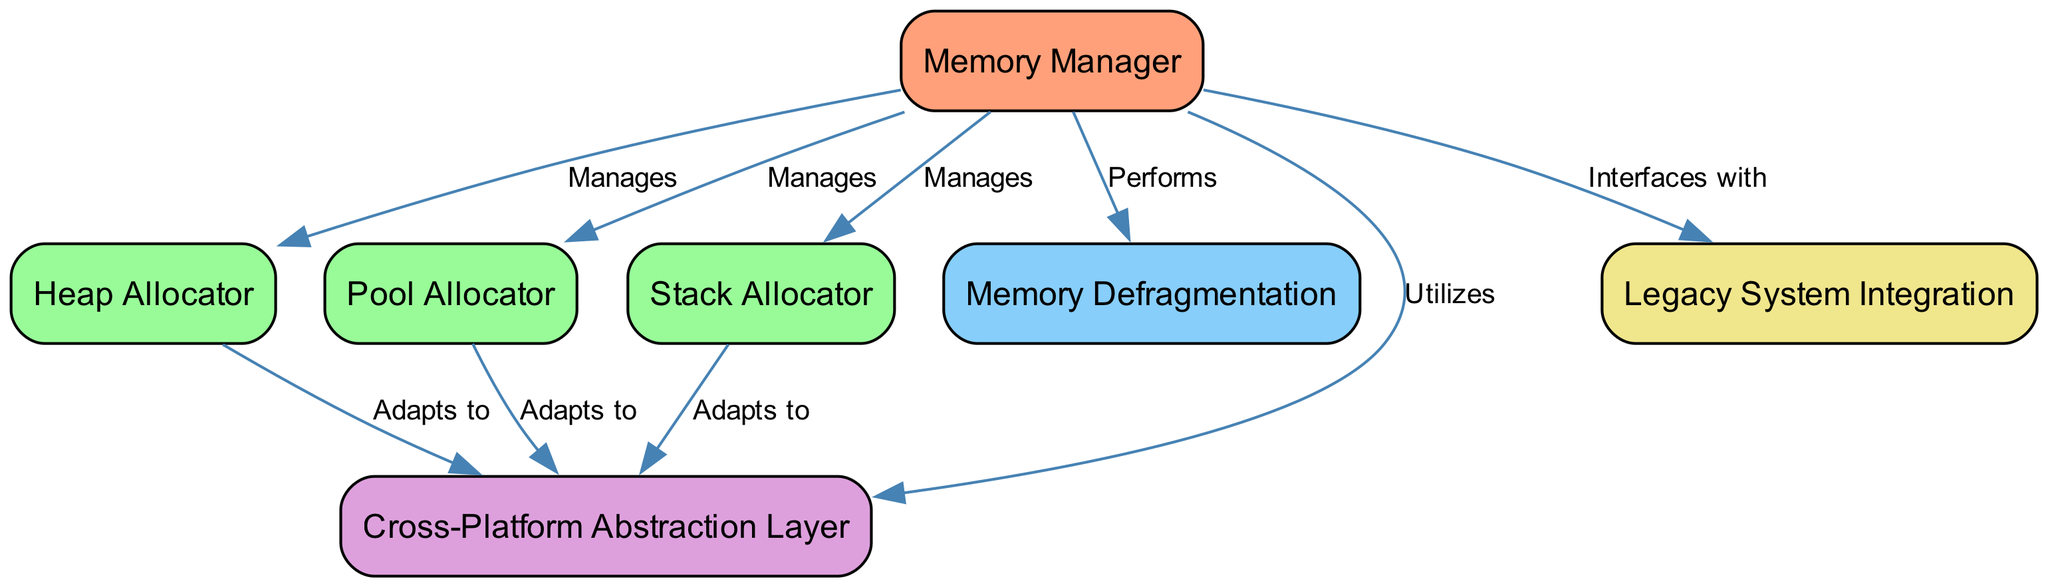What is the central component that manages all memory types? The diagram indicates that the "Memory Manager" is the central node that "Manages" various types of memory allocation, including Heap Allocator, Pool Allocator, and Stack Allocator.
Answer: Memory Manager How many types of allocators are managed by the Memory Manager? The diagram shows three specific allocators connected to the Memory Manager: Heap Allocator, Pool Allocator, and Stack Allocator. Thus, the count is three.
Answer: Three What does the Memory Manager perform related to memory? According to the diagram, the Memory Manager "Performs" memory defragmentation, which is represented by the edge labeled "Performs" pointing to "Memory Defragmentation."
Answer: Memory Defragmentation Which layer does the Memory Manager utilize for cross-platform compatibility? The diagram shows that the Memory Manager "Utilizes" the "Cross-Platform Abstraction Layer," indicating that it depends on this layer for managing memory across different platforms.
Answer: Cross-Platform Abstraction Layer How do the allocators adapt to the cross-platform layer? The diagram shows each of the allocators (Heap Allocator, Pool Allocator, Stack Allocator) connecting to the Cross-Platform Abstraction Layer with the label "Adapts to," indicating that they are designed to adjust their allocation strategies based on this layer.
Answer: Adapts to What is the relationship between the Memory Manager and Legacy System Integration? The diagram illustrates that the Memory Manager "Interfaces with" the Legacy System Integration, indicating a relationship where the Memory Manager works with or connects to legacy systems.
Answer: Interfaces with Which allocator is responsible for stack-based memory management? The diagram indicates that the "Stack Allocator" is managed by the Memory Manager, highlighting its role specifically for stack memory allocation.
Answer: Stack Allocator How many edges connect to the Memory Manager? The diagram visually represents a total of five edges going out from the Memory Manager, connecting it to various components including allocators, defragmentation, an abstraction layer, and legacy systems.
Answer: Five What process does the Memory Manager carry out to optimize memory usage? The diagram specifies that the "Memory Manager" "Performs" "Memory Defragmentation," which is a process used to optimize memory usage by consolidating free memory spaces.
Answer: Memory Defragmentation 